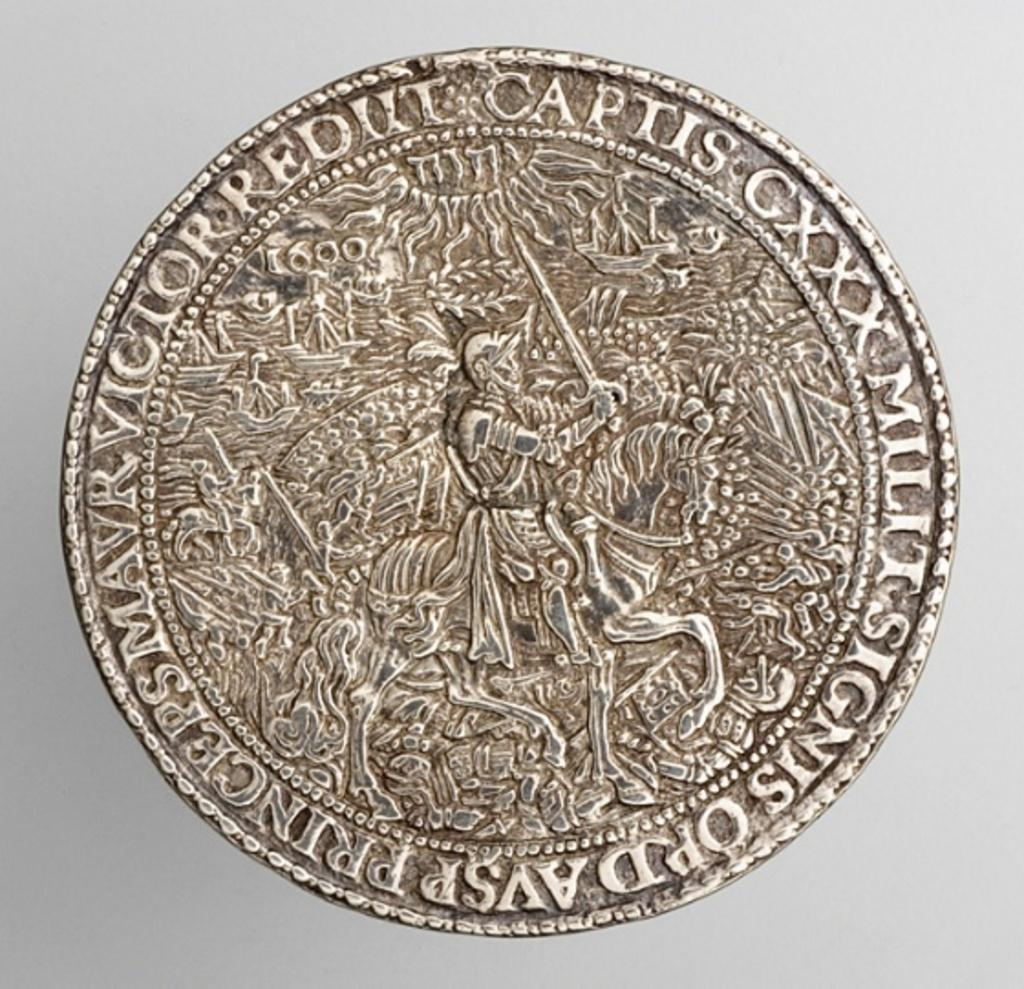<image>
Share a concise interpretation of the image provided. A coin has the Roman numeral CXXX printed on it. 